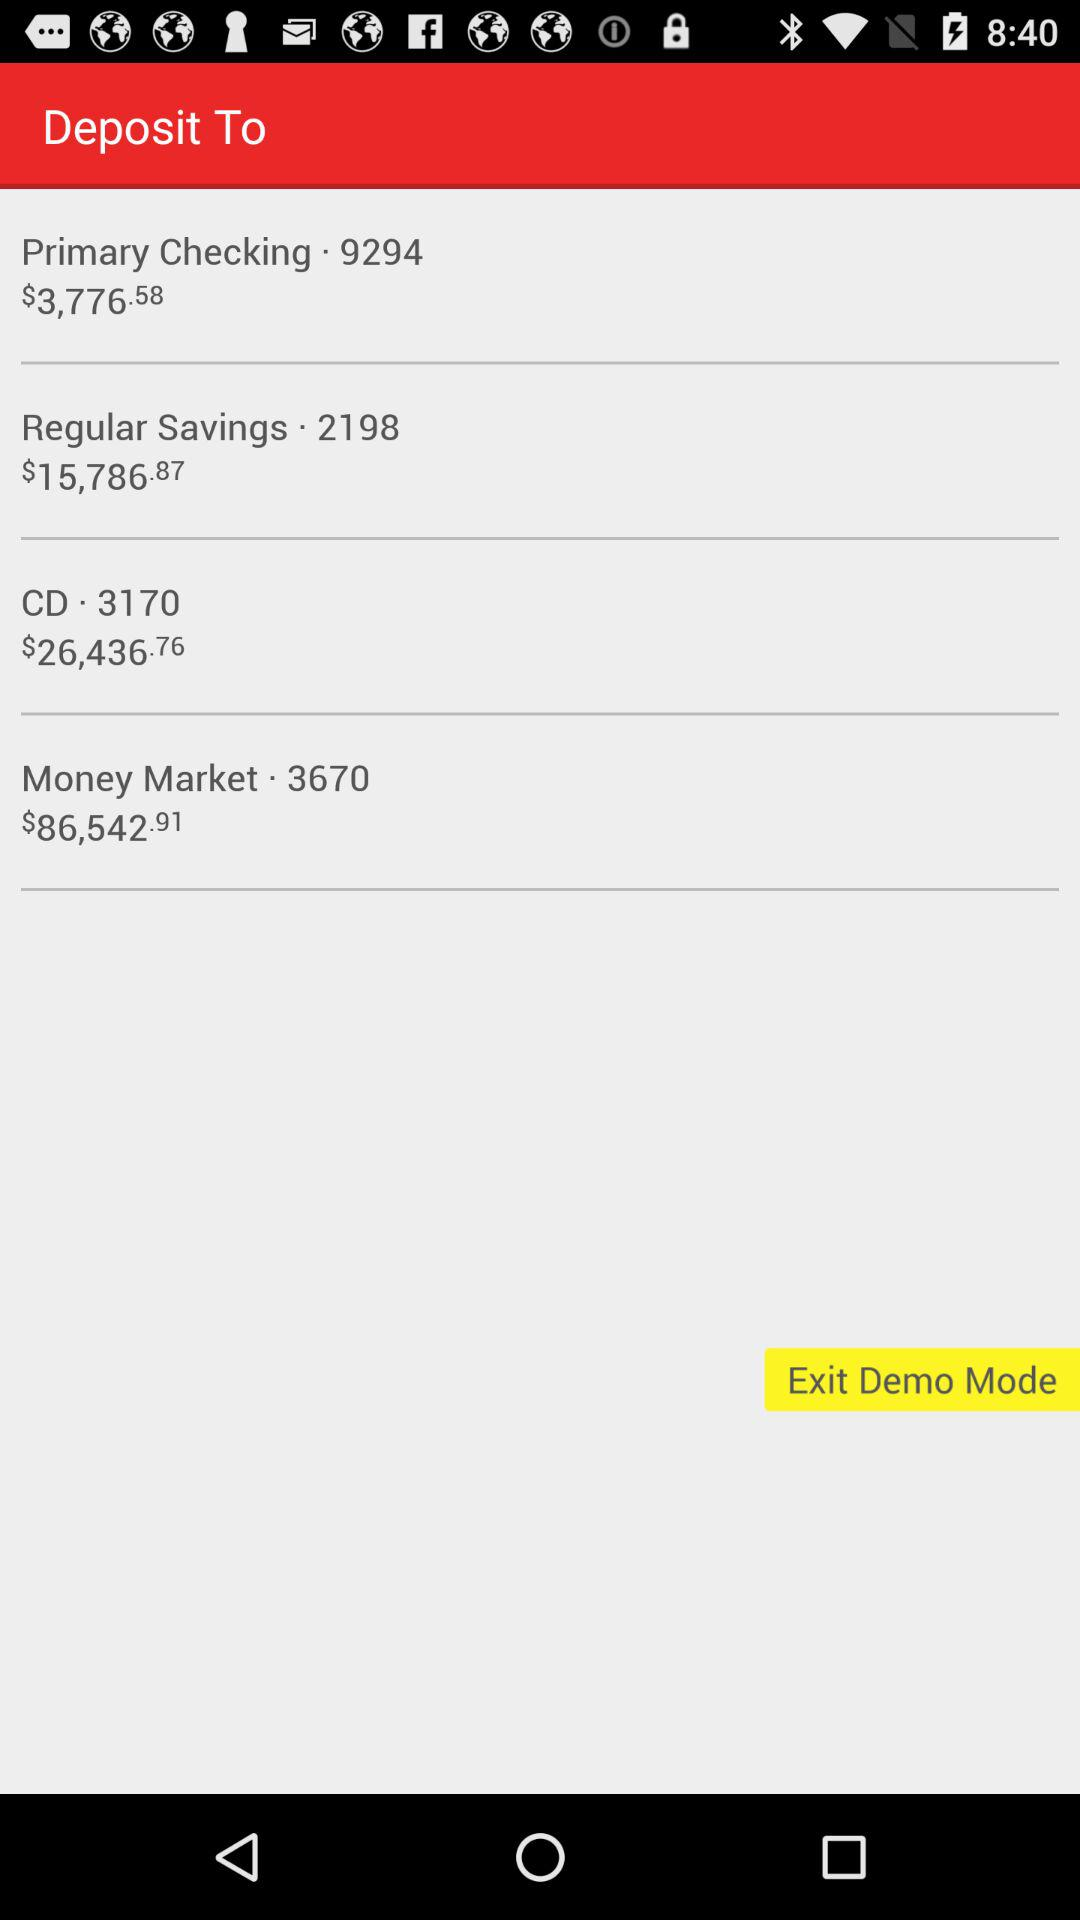What is the amount mentioned in "Money Market"? The amount mentioned in "Money Market" is $86,542.91. 